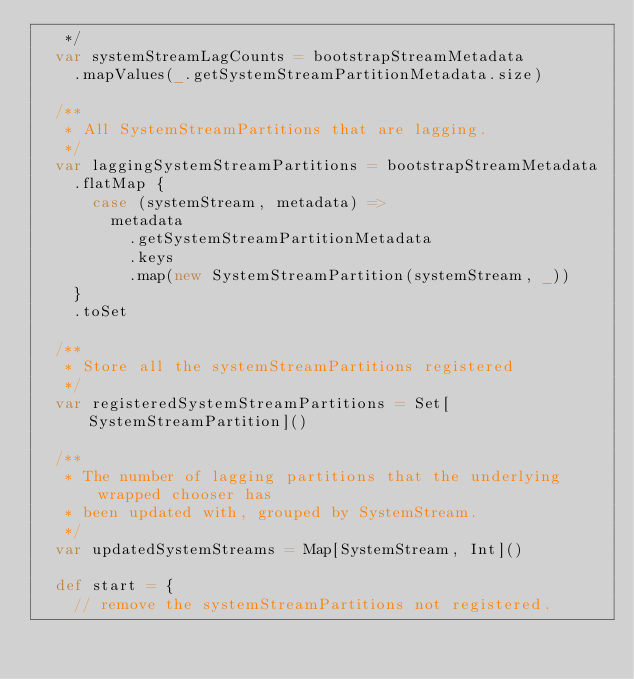<code> <loc_0><loc_0><loc_500><loc_500><_Scala_>   */
  var systemStreamLagCounts = bootstrapStreamMetadata
    .mapValues(_.getSystemStreamPartitionMetadata.size)

  /**
   * All SystemStreamPartitions that are lagging.
   */
  var laggingSystemStreamPartitions = bootstrapStreamMetadata
    .flatMap {
      case (systemStream, metadata) =>
        metadata
          .getSystemStreamPartitionMetadata
          .keys
          .map(new SystemStreamPartition(systemStream, _))
    }
    .toSet

  /**
   * Store all the systemStreamPartitions registered
   */
  var registeredSystemStreamPartitions = Set[SystemStreamPartition]()

  /**
   * The number of lagging partitions that the underlying wrapped chooser has
   * been updated with, grouped by SystemStream.
   */
  var updatedSystemStreams = Map[SystemStream, Int]()

  def start = {
    // remove the systemStreamPartitions not registered.</code> 